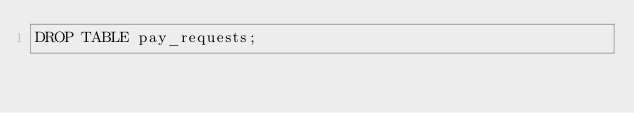<code> <loc_0><loc_0><loc_500><loc_500><_SQL_>DROP TABLE pay_requests;</code> 